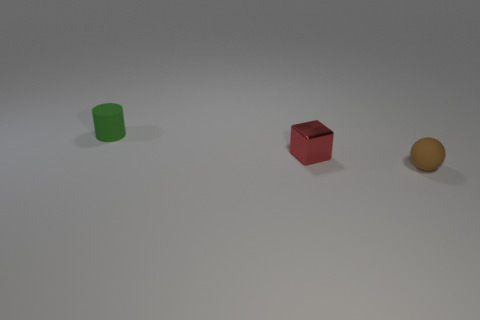What number of objects are either things behind the tiny red shiny object or things that are in front of the red cube?
Ensure brevity in your answer.  2. There is a rubber object that is in front of the tiny green thing left of the red metal thing; how big is it?
Offer a terse response. Small. Does the tiny matte object behind the tiny red metal thing have the same color as the tiny rubber sphere?
Offer a terse response. No. Is there another metal thing of the same shape as the tiny red metal thing?
Provide a short and direct response. No. What is the color of the rubber sphere that is the same size as the red block?
Keep it short and to the point. Brown. There is a matte object right of the tiny red shiny block; how big is it?
Ensure brevity in your answer.  Small. There is a tiny matte thing on the left side of the brown object; are there any brown matte things that are behind it?
Offer a very short reply. No. Is the material of the object that is on the left side of the small metallic object the same as the brown sphere?
Provide a succinct answer. Yes. What number of small objects are both behind the tiny sphere and in front of the tiny cylinder?
Give a very brief answer. 1. What number of tiny green cylinders are the same material as the small brown ball?
Your response must be concise. 1. 